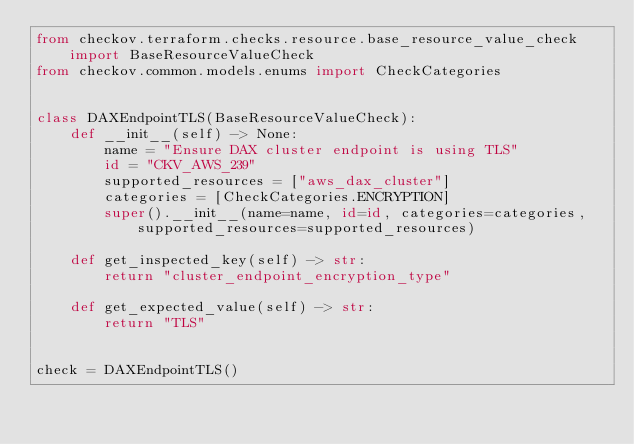Convert code to text. <code><loc_0><loc_0><loc_500><loc_500><_Python_>from checkov.terraform.checks.resource.base_resource_value_check import BaseResourceValueCheck
from checkov.common.models.enums import CheckCategories


class DAXEndpointTLS(BaseResourceValueCheck):
    def __init__(self) -> None:
        name = "Ensure DAX cluster endpoint is using TLS"
        id = "CKV_AWS_239"
        supported_resources = ["aws_dax_cluster"]
        categories = [CheckCategories.ENCRYPTION]
        super().__init__(name=name, id=id, categories=categories, supported_resources=supported_resources)

    def get_inspected_key(self) -> str:
        return "cluster_endpoint_encryption_type"

    def get_expected_value(self) -> str:
        return "TLS"


check = DAXEndpointTLS()
</code> 